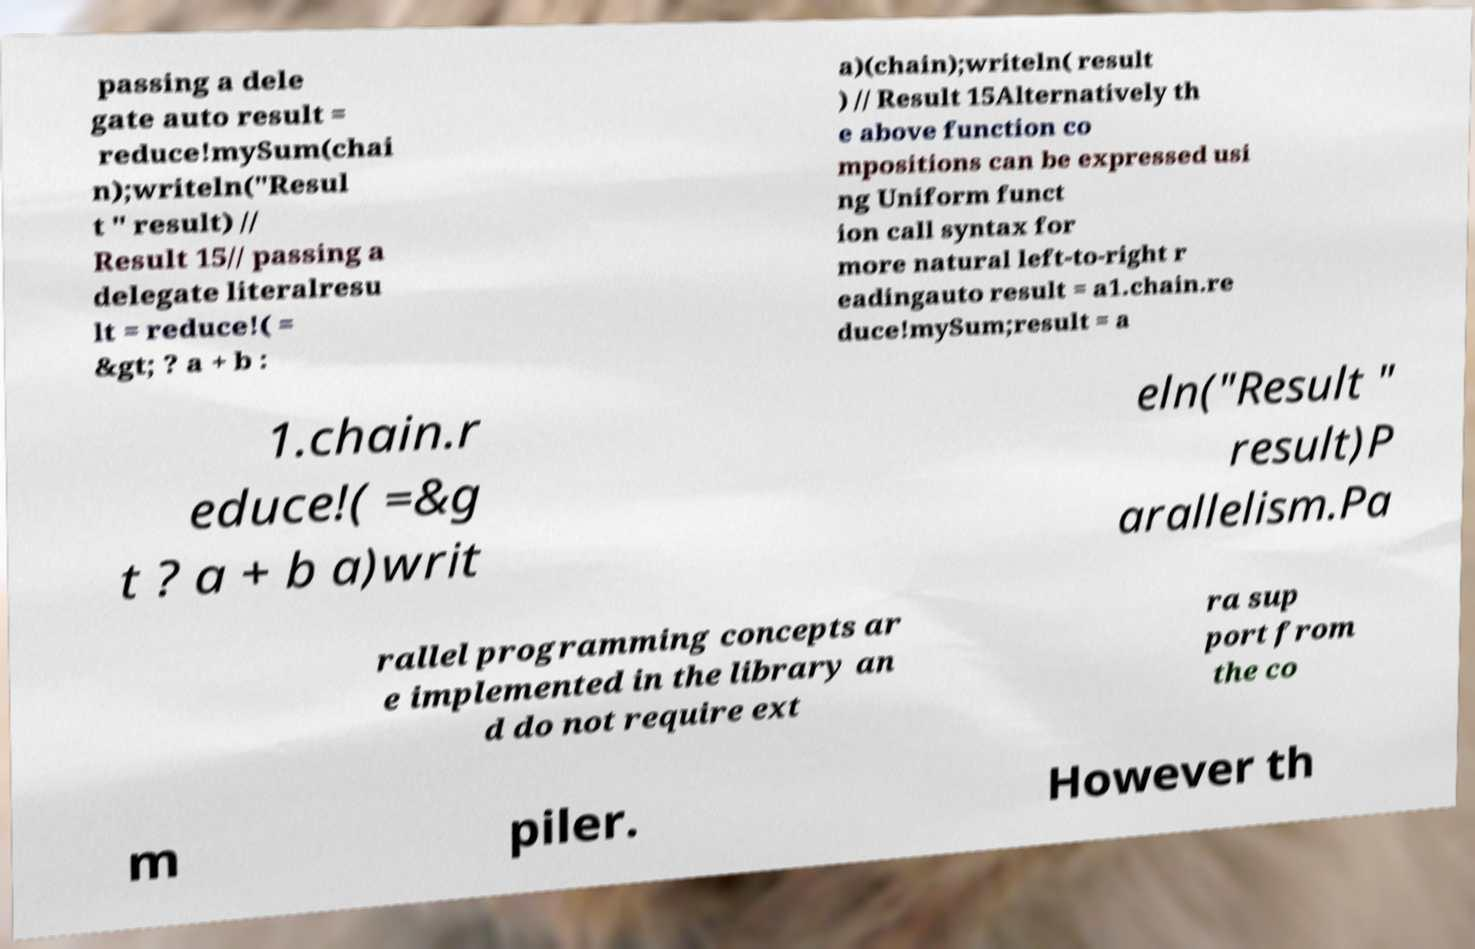For documentation purposes, I need the text within this image transcribed. Could you provide that? passing a dele gate auto result = reduce!mySum(chai n);writeln("Resul t " result) // Result 15// passing a delegate literalresu lt = reduce!( = &gt; ? a + b : a)(chain);writeln( result ) // Result 15Alternatively th e above function co mpositions can be expressed usi ng Uniform funct ion call syntax for more natural left-to-right r eadingauto result = a1.chain.re duce!mySum;result = a 1.chain.r educe!( =&g t ? a + b a)writ eln("Result " result)P arallelism.Pa rallel programming concepts ar e implemented in the library an d do not require ext ra sup port from the co m piler. However th 